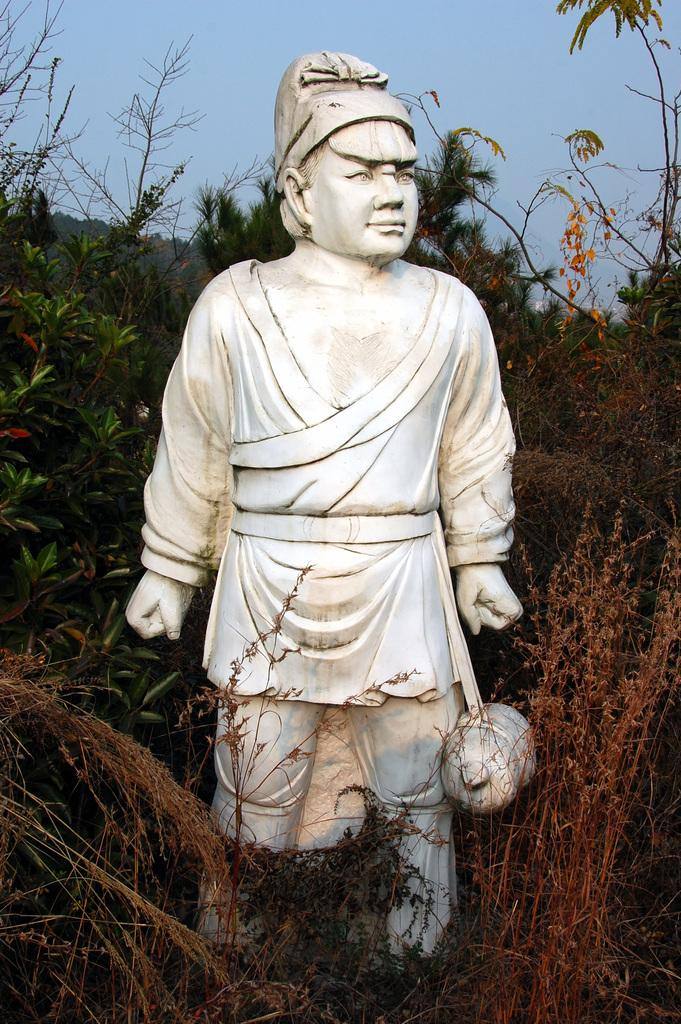What is the main subject in the image? There is a statue in the image. What other elements can be seen in the image? There are plants, trees, and the sky visible in the image. Can you describe the condition of some of the plants in the image? Some of the plants appear to be dried at the bottom. Where are the wrens nesting in the image? There are no wrens or nests present in the image. What type of can is visible in the image? There is no can present in the image. 